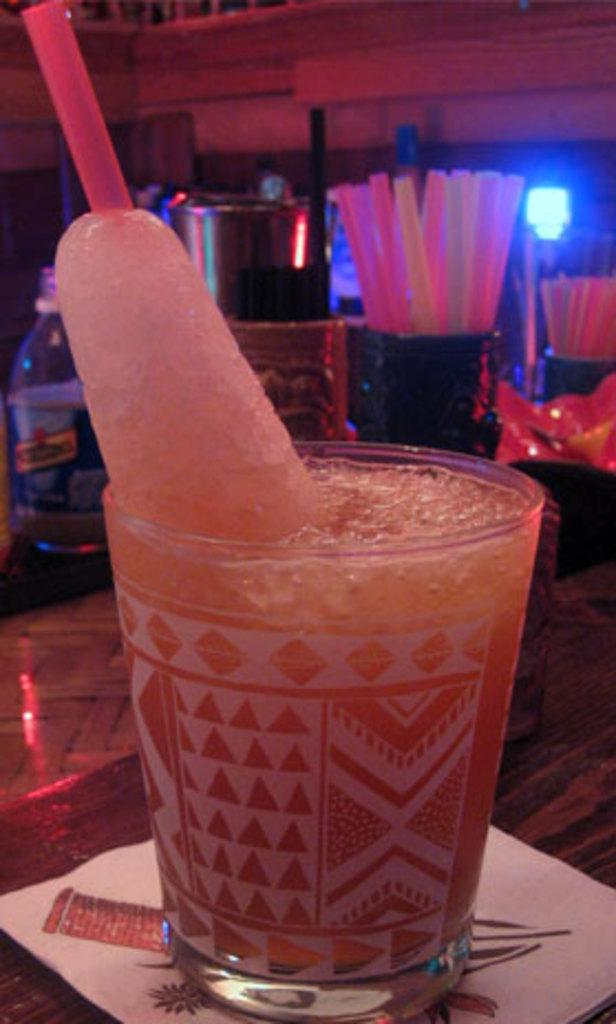What is the main subject of the image? There is an ice gola in a glass in the image. Where is the glass with the ice gola placed? The glass is placed on a table. Can you describe any other items visible in the image? The provided facts do not mention any other items visible in the image. What type of fingerprint can be seen on the glass in the image? There is no fingerprint visible on the glass in the image. 